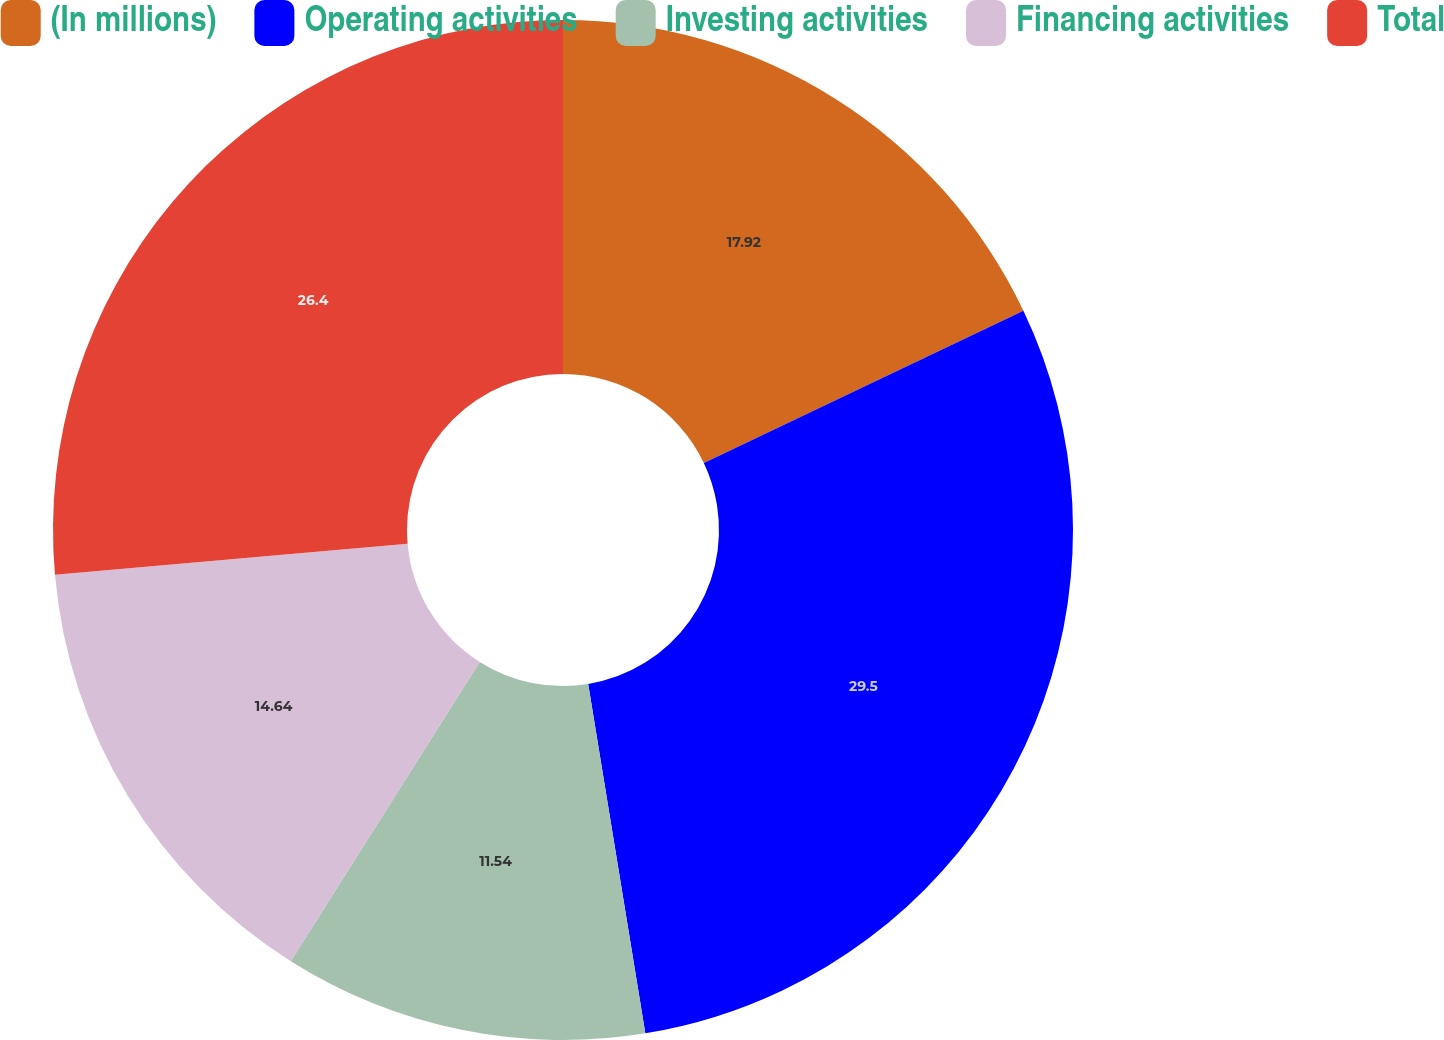<chart> <loc_0><loc_0><loc_500><loc_500><pie_chart><fcel>(In millions)<fcel>Operating activities<fcel>Investing activities<fcel>Financing activities<fcel>Total<nl><fcel>17.92%<fcel>29.49%<fcel>11.54%<fcel>14.64%<fcel>26.39%<nl></chart> 